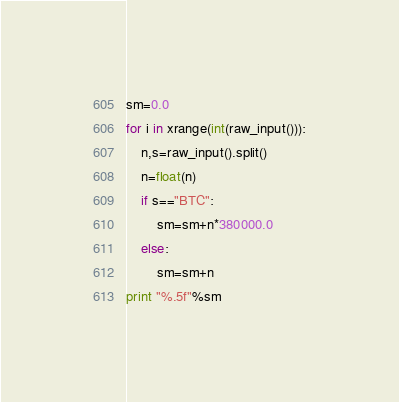<code> <loc_0><loc_0><loc_500><loc_500><_Python_>sm=0.0
for i in xrange(int(raw_input())):
	n,s=raw_input().split()
	n=float(n)
	if s=="BTC":
		sm=sm+n*380000.0
	else:
		sm=sm+n
print "%.5f"%sm
</code> 